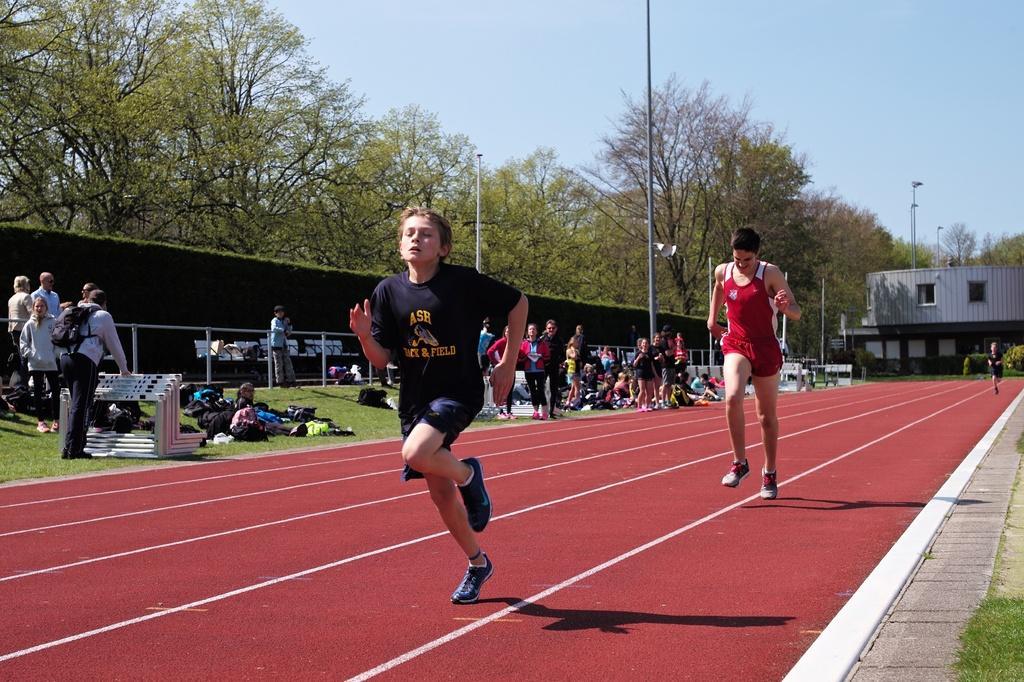Could you give a brief overview of what you see in this image? In this picture I can see there are two people running and they are wearing jersey´s and there are few people sitting and standing on the left. There is a building in the backdrop and there are plants and trees and the sky is clear. 